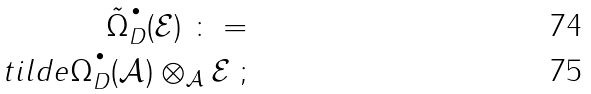<formula> <loc_0><loc_0><loc_500><loc_500>\tilde { \Omega } _ { D } ^ { \, ^ { \bullet } } ( { \mathcal { E } } ) \ \colon = \\ t i l d e { \Omega } _ { D } ^ { \, ^ { \bullet } } ( { \mathcal { A } } ) \otimes _ { \mathcal { A } } { \mathcal { E } } \ ;</formula> 